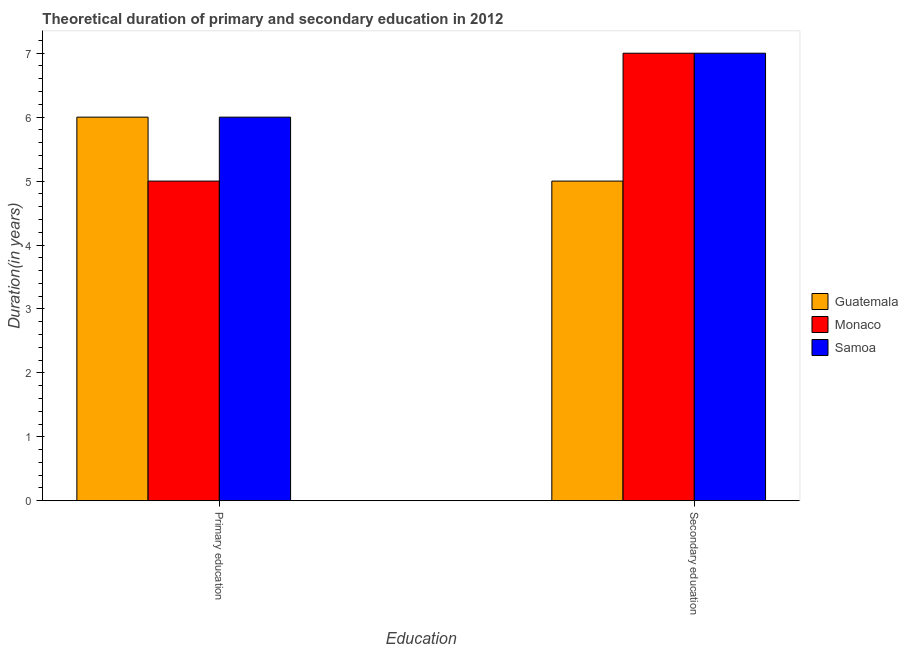How many different coloured bars are there?
Your response must be concise. 3. How many groups of bars are there?
Give a very brief answer. 2. Are the number of bars per tick equal to the number of legend labels?
Your answer should be very brief. Yes. Are the number of bars on each tick of the X-axis equal?
Offer a terse response. Yes. Across all countries, what is the minimum duration of primary education?
Make the answer very short. 5. In which country was the duration of secondary education maximum?
Provide a succinct answer. Monaco. In which country was the duration of secondary education minimum?
Provide a succinct answer. Guatemala. What is the total duration of primary education in the graph?
Keep it short and to the point. 17. What is the difference between the duration of primary education in Guatemala and the duration of secondary education in Samoa?
Keep it short and to the point. -1. What is the average duration of secondary education per country?
Your answer should be very brief. 6.33. What is the difference between the duration of primary education and duration of secondary education in Guatemala?
Offer a terse response. 1. In how many countries, is the duration of primary education greater than 2.8 years?
Your answer should be very brief. 3. What is the ratio of the duration of primary education in Samoa to that in Guatemala?
Your answer should be very brief. 1. Is the duration of primary education in Guatemala less than that in Samoa?
Provide a short and direct response. No. What does the 3rd bar from the left in Secondary education represents?
Ensure brevity in your answer.  Samoa. What does the 2nd bar from the right in Secondary education represents?
Your answer should be compact. Monaco. How many bars are there?
Provide a short and direct response. 6. Are all the bars in the graph horizontal?
Make the answer very short. No. Are the values on the major ticks of Y-axis written in scientific E-notation?
Your response must be concise. No. Does the graph contain grids?
Give a very brief answer. No. What is the title of the graph?
Ensure brevity in your answer.  Theoretical duration of primary and secondary education in 2012. What is the label or title of the X-axis?
Make the answer very short. Education. What is the label or title of the Y-axis?
Offer a very short reply. Duration(in years). What is the Duration(in years) of Guatemala in Primary education?
Provide a succinct answer. 6. What is the Duration(in years) in Monaco in Primary education?
Provide a succinct answer. 5. What is the Duration(in years) of Samoa in Primary education?
Offer a very short reply. 6. What is the Duration(in years) of Guatemala in Secondary education?
Your answer should be compact. 5. What is the Duration(in years) of Monaco in Secondary education?
Your response must be concise. 7. Across all Education, what is the maximum Duration(in years) in Samoa?
Make the answer very short. 7. Across all Education, what is the minimum Duration(in years) in Guatemala?
Give a very brief answer. 5. What is the total Duration(in years) of Guatemala in the graph?
Provide a succinct answer. 11. What is the total Duration(in years) of Monaco in the graph?
Keep it short and to the point. 12. What is the difference between the Duration(in years) of Monaco in Primary education and that in Secondary education?
Your answer should be very brief. -2. What is the difference between the Duration(in years) in Guatemala in Primary education and the Duration(in years) in Samoa in Secondary education?
Keep it short and to the point. -1. What is the difference between the Duration(in years) in Monaco in Primary education and the Duration(in years) in Samoa in Secondary education?
Give a very brief answer. -2. What is the average Duration(in years) in Monaco per Education?
Your response must be concise. 6. What is the difference between the Duration(in years) in Guatemala and Duration(in years) in Monaco in Primary education?
Ensure brevity in your answer.  1. What is the difference between the Duration(in years) in Monaco and Duration(in years) in Samoa in Primary education?
Your answer should be very brief. -1. What is the difference between the Duration(in years) of Guatemala and Duration(in years) of Monaco in Secondary education?
Provide a succinct answer. -2. What is the ratio of the Duration(in years) of Guatemala in Primary education to that in Secondary education?
Offer a terse response. 1.2. What is the ratio of the Duration(in years) of Samoa in Primary education to that in Secondary education?
Your answer should be very brief. 0.86. What is the difference between the highest and the second highest Duration(in years) of Guatemala?
Your response must be concise. 1. What is the difference between the highest and the second highest Duration(in years) in Monaco?
Offer a terse response. 2. What is the difference between the highest and the lowest Duration(in years) of Guatemala?
Ensure brevity in your answer.  1. 